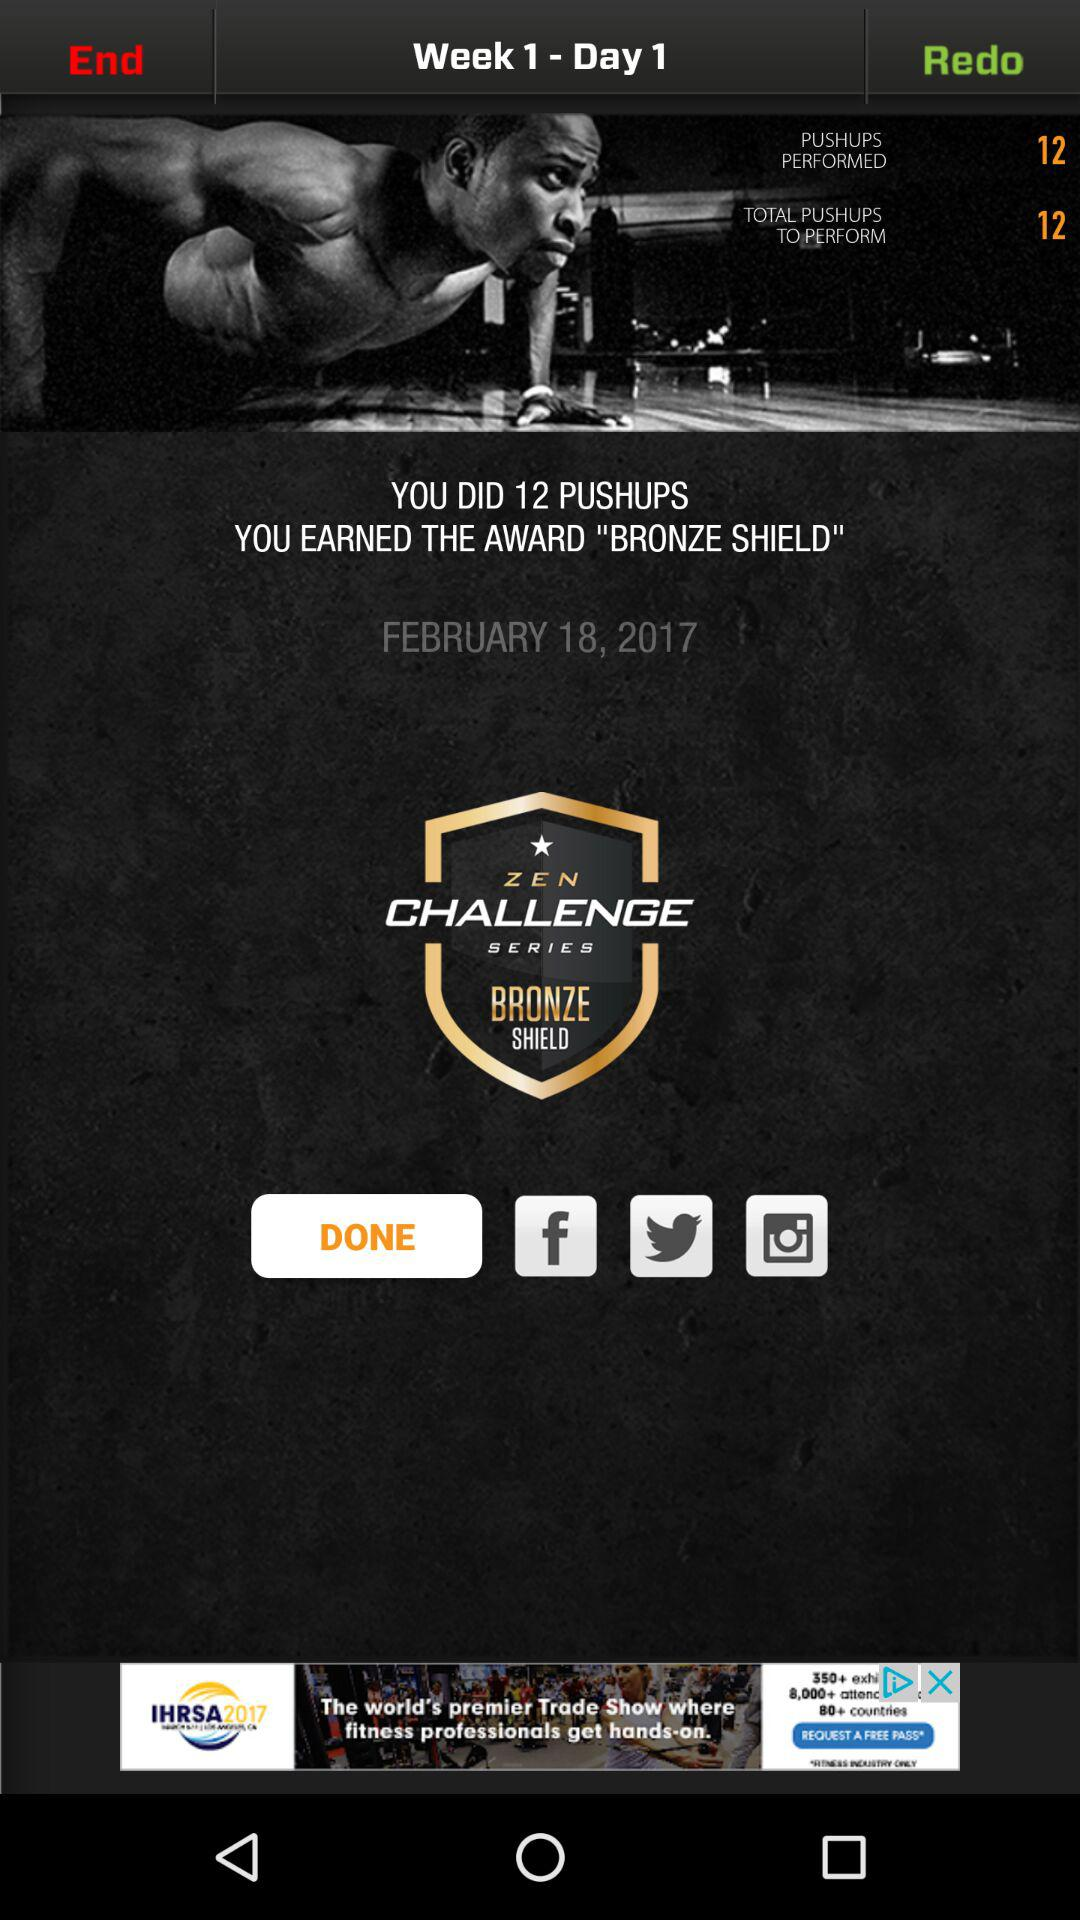What is the date? The date is February 18, 2017. 